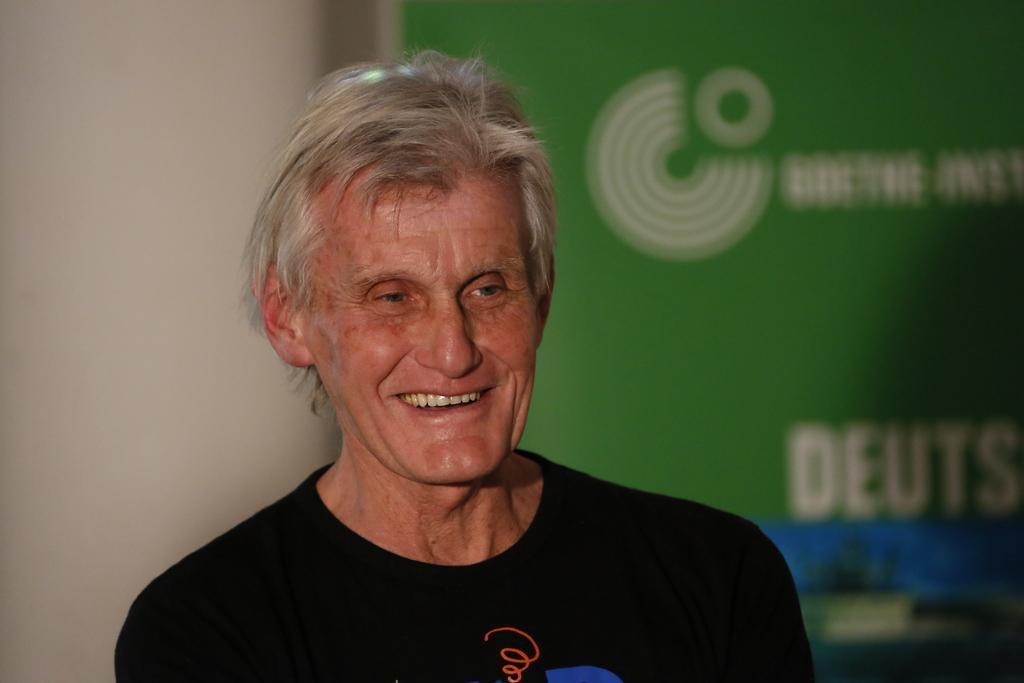Who is the main subject in the image? There is a person in the center of the image. What is the person wearing? The person is wearing a black dress. What expression does the person have? The person is smiling. What can be seen in the background of the image? There is a wall and text on a banner in the background of the image. What type of pan is being used to cook food in the image? There is no pan or cooking activity present in the image. Is there a camp visible in the background of the image? There is no camp visible in the image; only a wall and text on a banner are present in the background. 